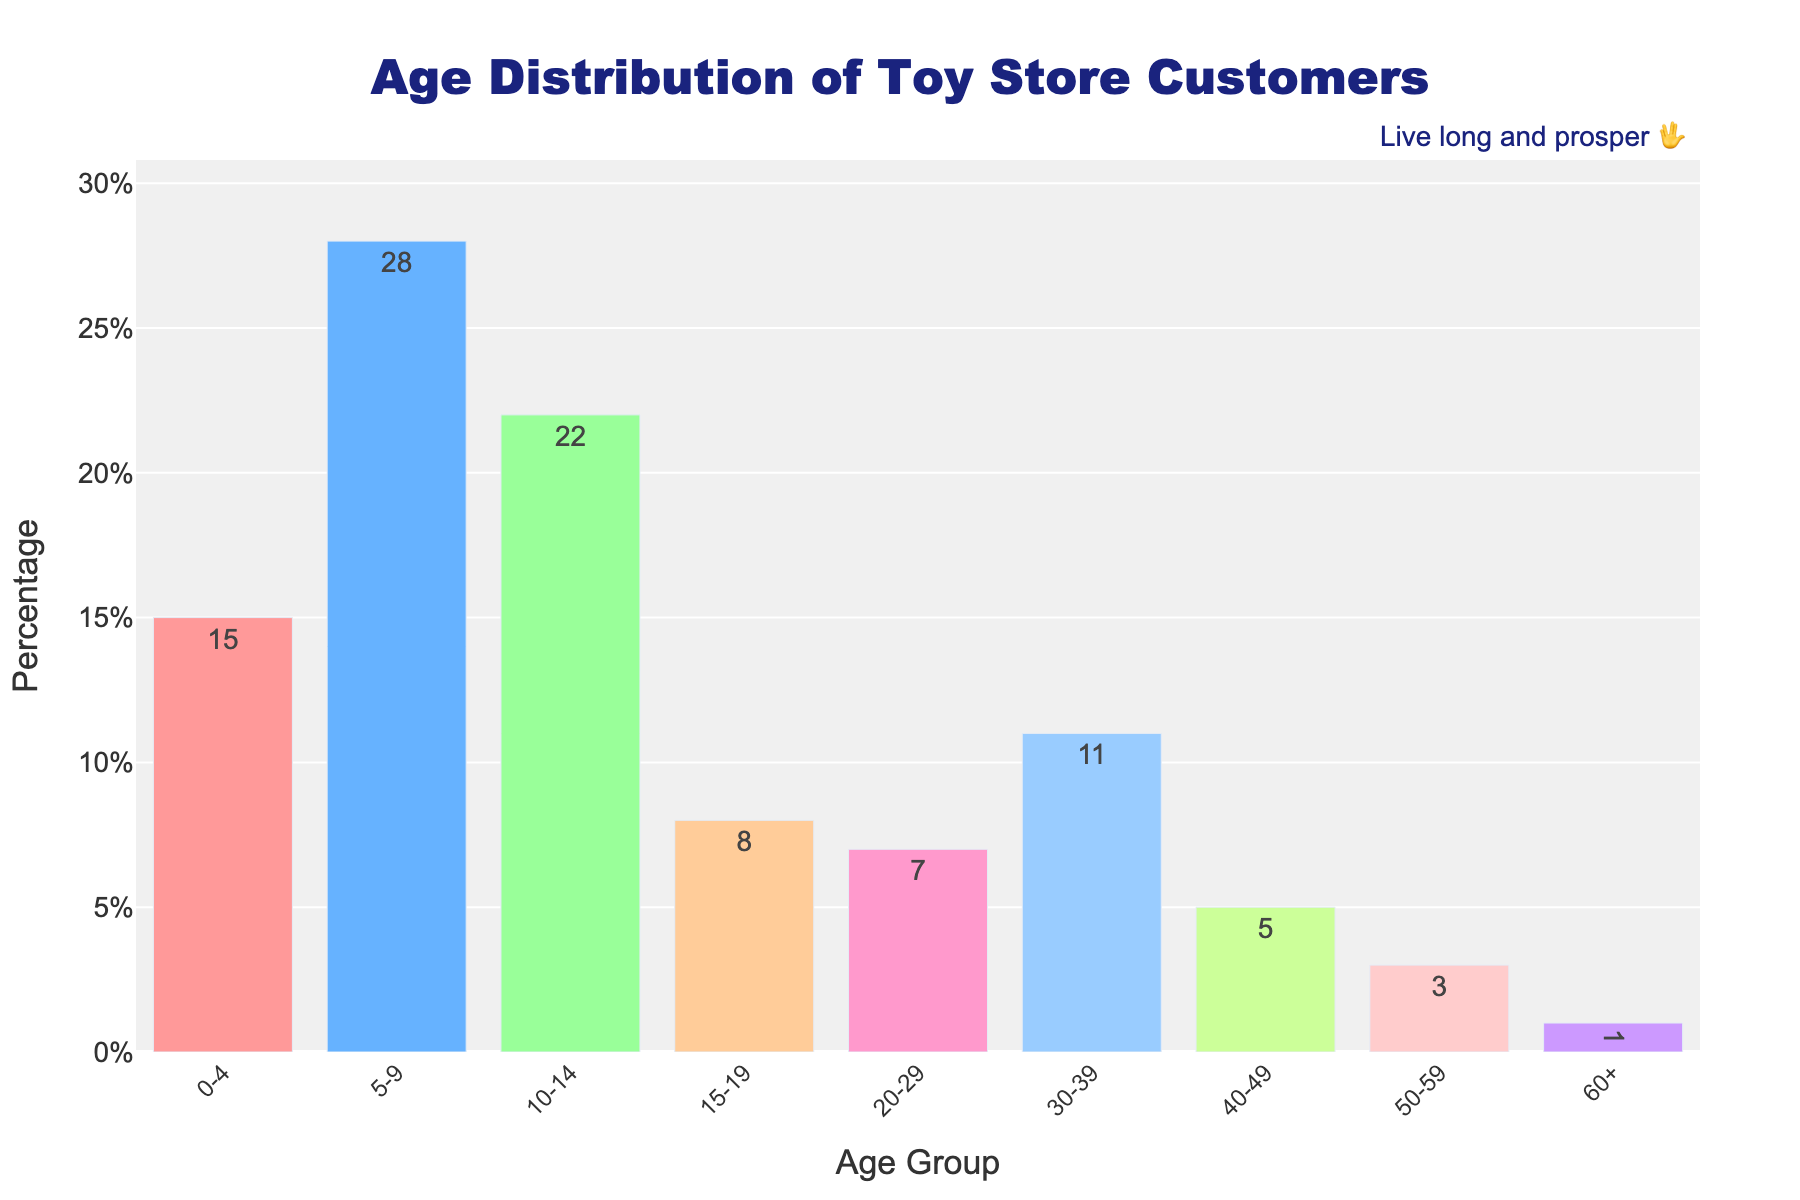What age group has the highest percentage of toy store customers? The age group with the highest percentage of toy store customers can be identified by looking for the tallest bar in the chart. The tallest bar corresponds to the 5-9 age group with a percentage of 28.
Answer: 5-9 What is the total percentage of customers aged 0-14? Add the percentages for the age groups 0-4, 5-9, and 10-14. These are 15, 28, and 22, respectively. The total is 15 + 28 + 22 = 65%.
Answer: 65% How does the percentage of customers aged 15-19 compare to those aged 20-29? Look at the heights of the bars for the age groups 15-19 and 20-29. The 15-19 age group has a percentage of 8%, while the 20-29 age group has a percentage of 7%. Therefore, the 15-19 age group has a slightly higher percentage.
Answer: 15-19 has a higher percentage Which age group has the lowest percentage of toy store customers? Identify the shortest bar in the chart. The shortest bar corresponds to the 60+ age group, with a percentage of 1.
Answer: 60+ What is the combined percentage of toy store customers aged 30 and above? Add the percentages for the age groups 30-39, 40-49, 50-59, and 60+. These are 11, 5, 3, and 1, respectively. The total is 11 + 5 + 3 + 1 = 20%.
Answer: 20% How much greater is the percentage of customers aged 5-9 compared to those aged 40-49? Subtract the percentage of the 40-49 age group from the percentage of the 5-9 age group. These percentages are 28 and 5, respectively. The difference is 28 - 5 = 23%.
Answer: 23% What is the median value of the age group percentages? To find the median, list the percentages in ascending order: 1, 3, 5, 7, 8, 11, 15, 22, 28. The median value is the middle number in this ordered list, which is 8.
Answer: 8 Which two age groups have the closest percentages of toy store customers? Compare the differences between the percentages of the adjacent bars. The smallest difference is between the 15-19 and 20-29 age groups, with percentages of 8 and 7, respectively. The difference is 1%.
Answer: 15-19 and 20-29 What is the average percentage of customers in the age groups from 10-49? Add the percentages for the 10-14, 15-19, 20-29, 30-39, and 40-49 age groups. These are 22, 8, 7, 11, and 5, respectively. Sum these up: 22 + 8 + 7 + 11 + 5 = 53. Divide by the number of age groups (5): 53/5 = 10.6%.
Answer: 10.6% What age group has a percentage closest to 10%? Identify the bar with percentage closest to 10. The closest age group is 30-39 with a percentage of 11.
Answer: 30-39 